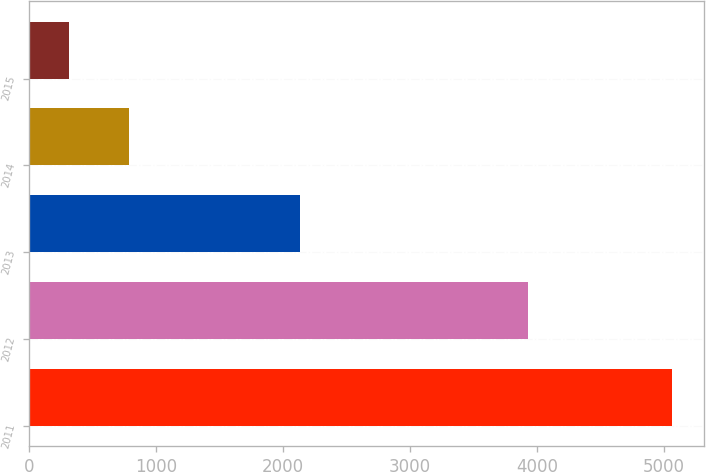Convert chart to OTSL. <chart><loc_0><loc_0><loc_500><loc_500><bar_chart><fcel>2011<fcel>2012<fcel>2013<fcel>2014<fcel>2015<nl><fcel>5061<fcel>3929<fcel>2133<fcel>789.6<fcel>315<nl></chart> 